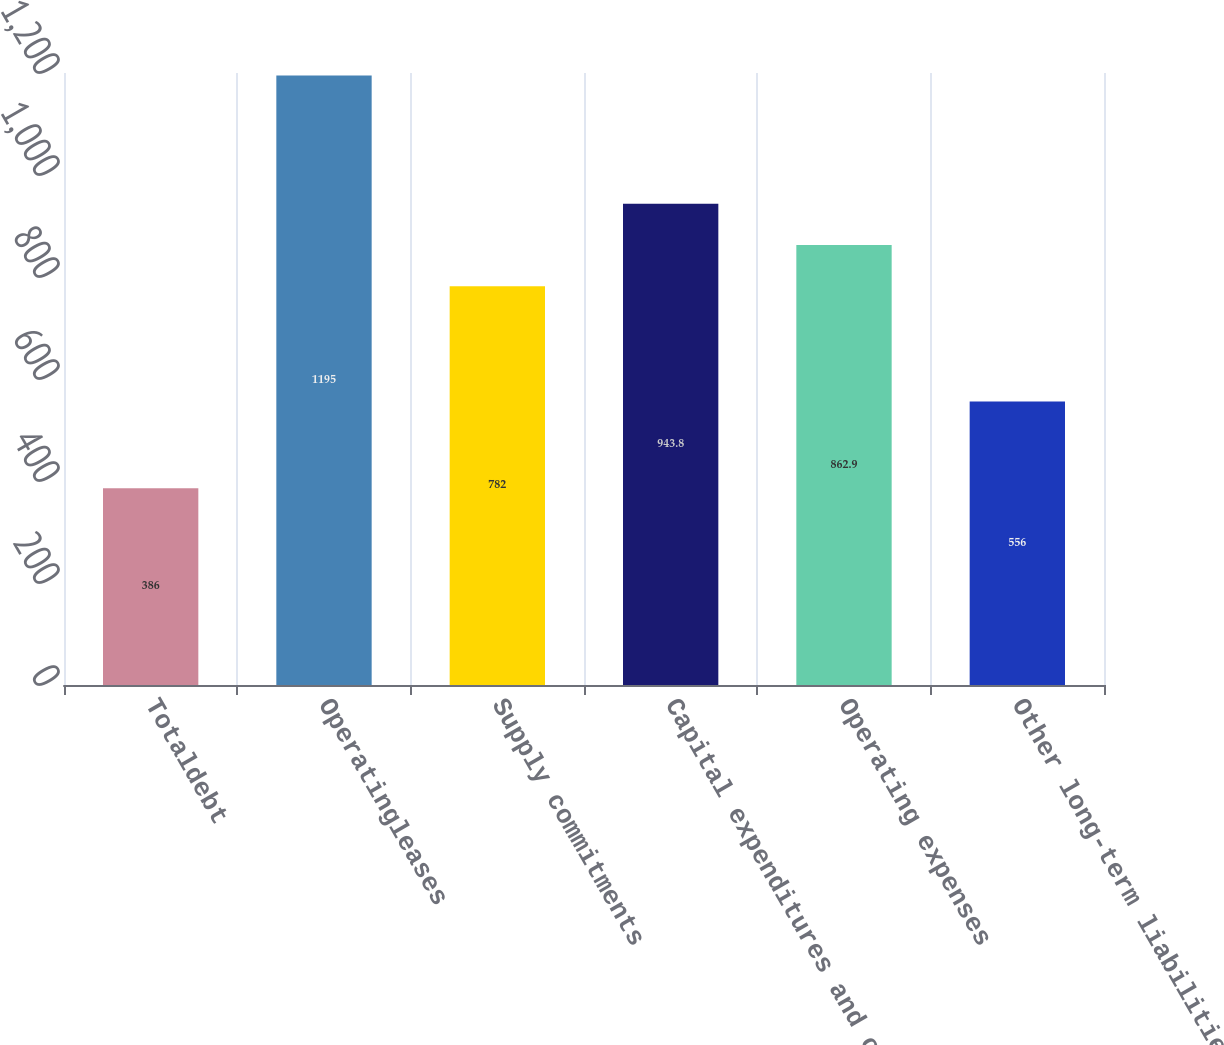Convert chart to OTSL. <chart><loc_0><loc_0><loc_500><loc_500><bar_chart><fcel>Totaldebt<fcel>Operatingleases<fcel>Supply commitments<fcel>Capital expenditures and other<fcel>Operating expenses<fcel>Other long-term liabilities<nl><fcel>386<fcel>1195<fcel>782<fcel>943.8<fcel>862.9<fcel>556<nl></chart> 